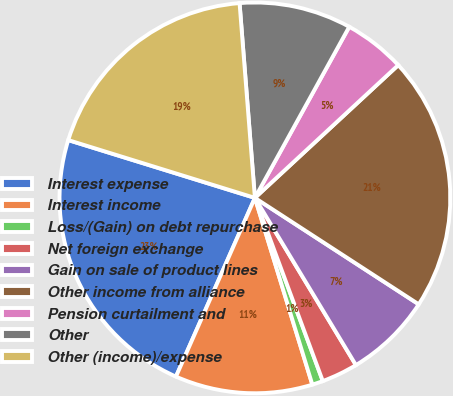Convert chart. <chart><loc_0><loc_0><loc_500><loc_500><pie_chart><fcel>Interest expense<fcel>Interest income<fcel>Loss/(Gain) on debt repurchase<fcel>Net foreign exchange<fcel>Gain on sale of product lines<fcel>Other income from alliance<fcel>Pension curtailment and<fcel>Other<fcel>Other (income)/expense<nl><fcel>23.16%<fcel>11.37%<fcel>0.9%<fcel>3.0%<fcel>7.18%<fcel>21.06%<fcel>5.09%<fcel>9.27%<fcel>18.97%<nl></chart> 